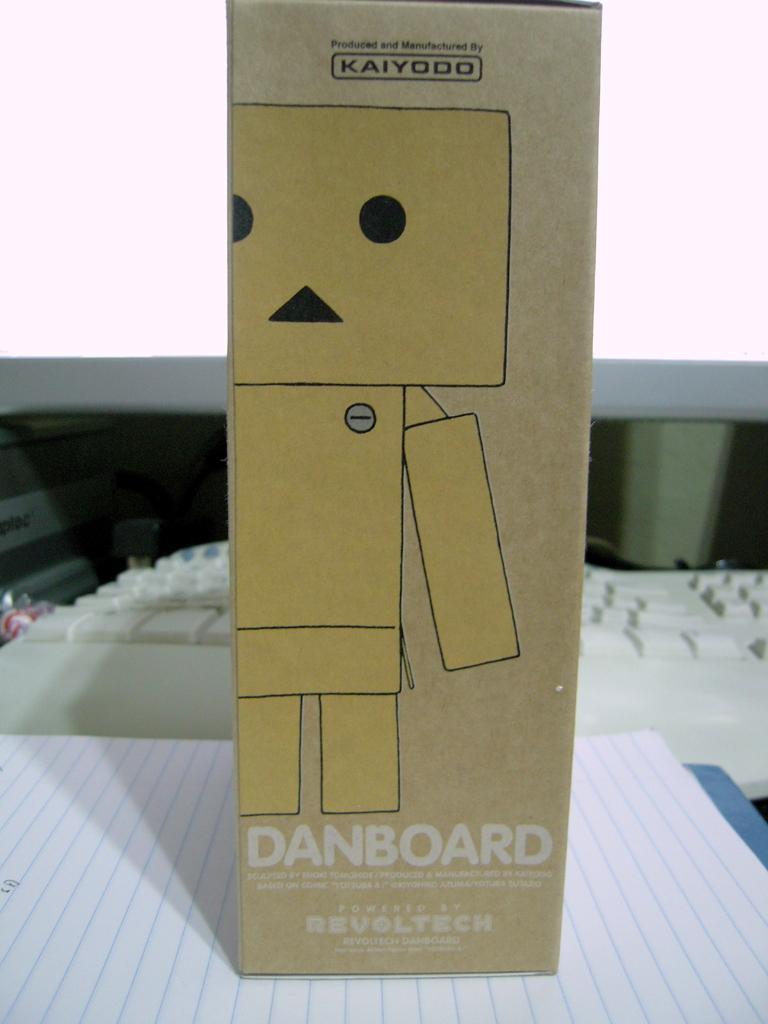What kind of cardboard is this?
Offer a terse response. Danboard. 